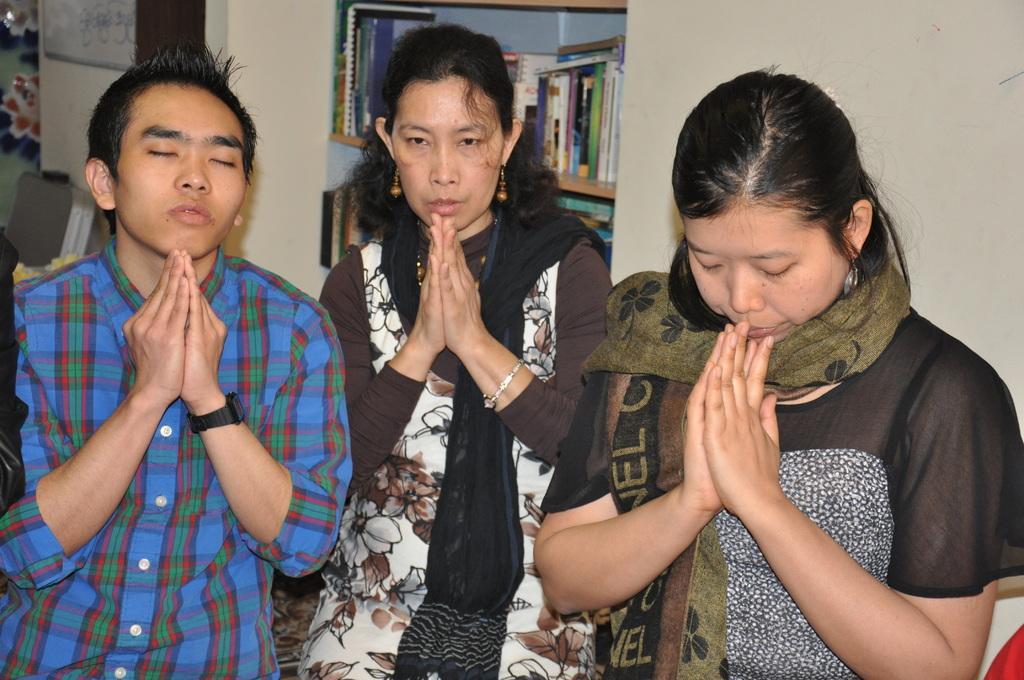Please provide a concise description of this image. In this picture I can see two women and women are joining their hands. In the background I can see a wall and a shelf which has books in it. 